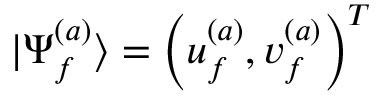Convert formula to latex. <formula><loc_0><loc_0><loc_500><loc_500>| \Psi _ { f } ^ { ( a ) } \rangle = \left ( u _ { f } ^ { ( a ) } , v _ { f } ^ { ( a ) } \right ) ^ { T }</formula> 